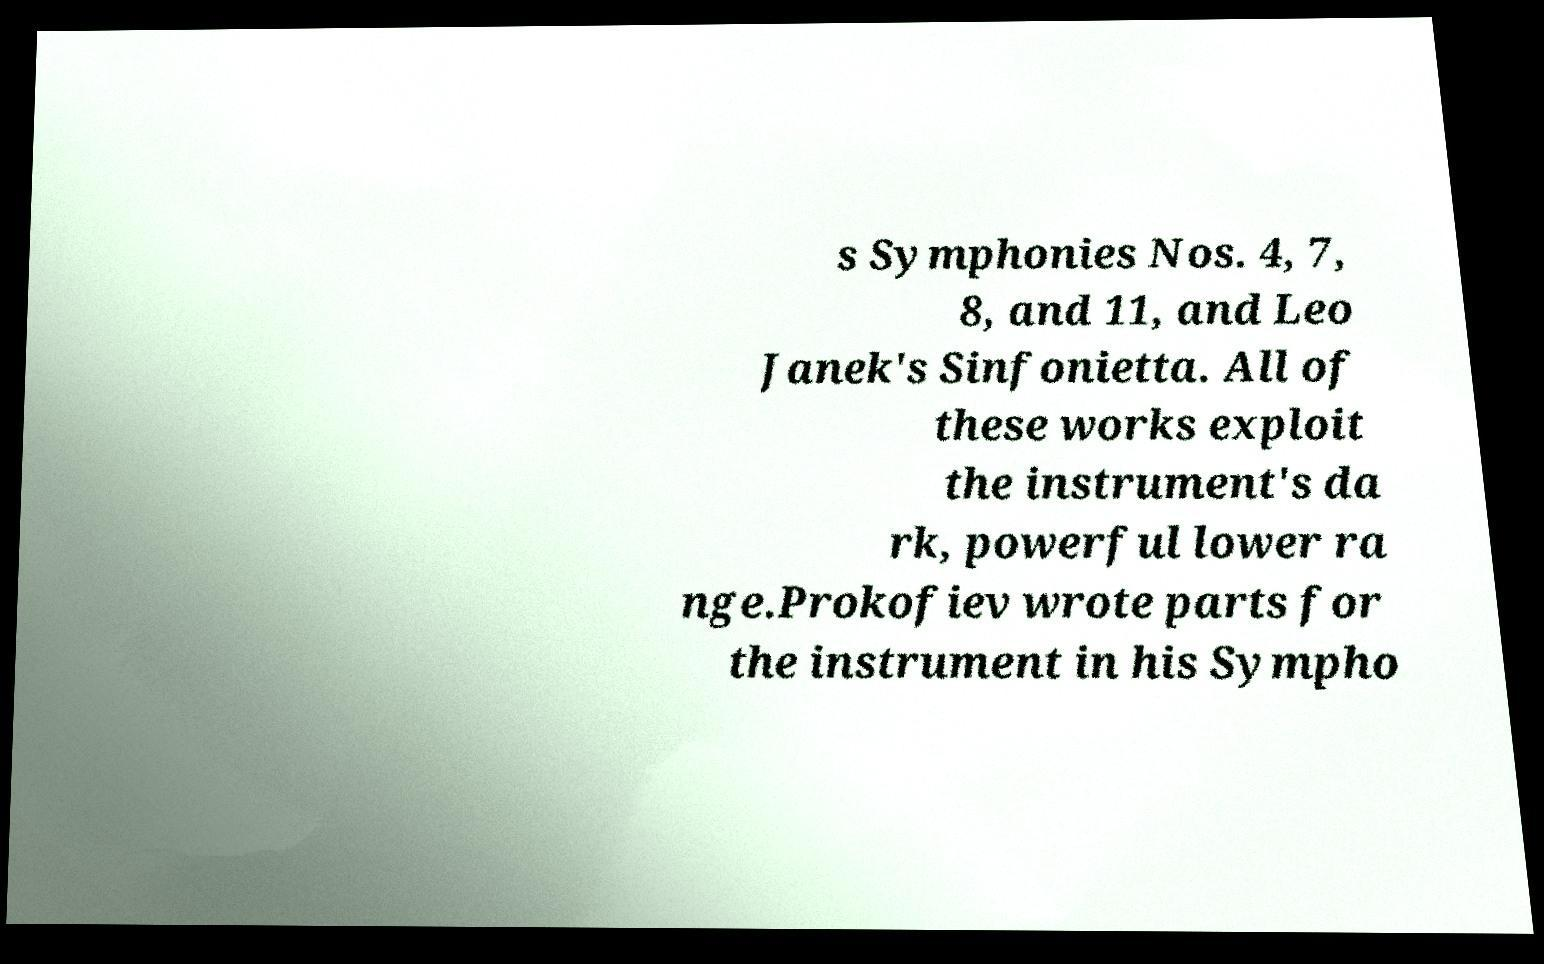For documentation purposes, I need the text within this image transcribed. Could you provide that? s Symphonies Nos. 4, 7, 8, and 11, and Leo Janek's Sinfonietta. All of these works exploit the instrument's da rk, powerful lower ra nge.Prokofiev wrote parts for the instrument in his Sympho 